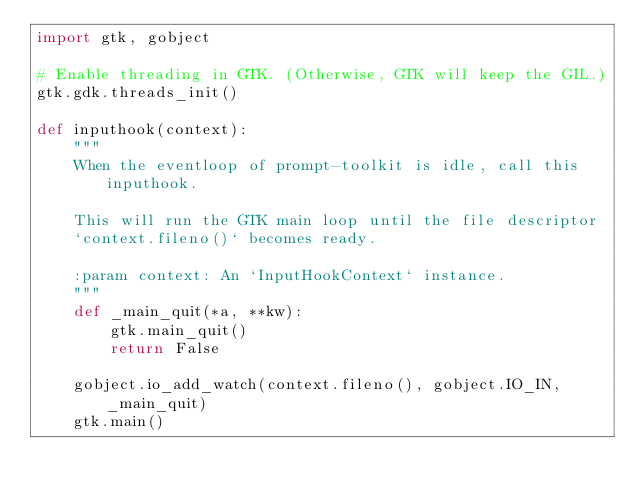<code> <loc_0><loc_0><loc_500><loc_500><_Python_>import gtk, gobject

# Enable threading in GTK. (Otherwise, GTK will keep the GIL.)
gtk.gdk.threads_init()

def inputhook(context):
    """
    When the eventloop of prompt-toolkit is idle, call this inputhook.

    This will run the GTK main loop until the file descriptor
    `context.fileno()` becomes ready.

    :param context: An `InputHookContext` instance.
    """
    def _main_quit(*a, **kw):
        gtk.main_quit()
        return False

    gobject.io_add_watch(context.fileno(), gobject.IO_IN, _main_quit)
    gtk.main()
</code> 